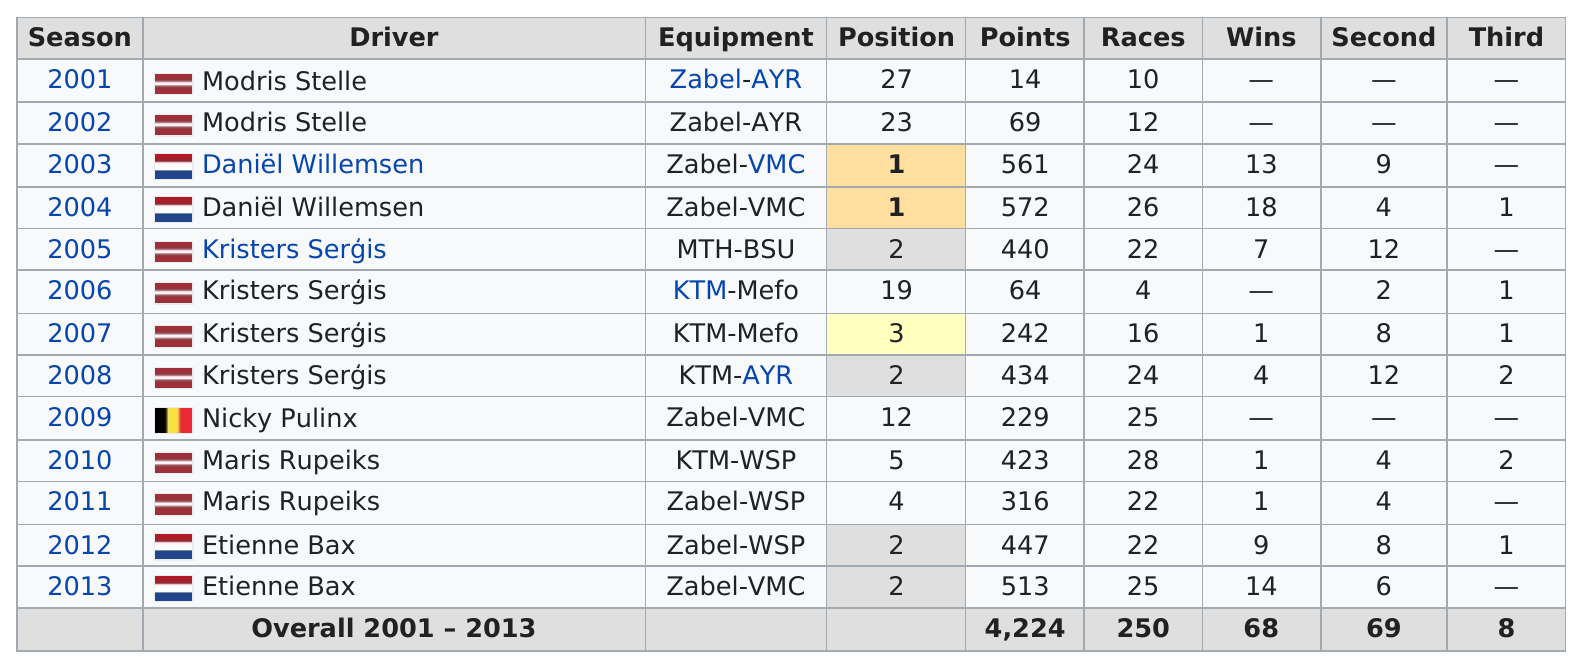Mention a couple of crucial points in this snapshot. During the 2001 season, Stelle obtained 14 points. The total number of races that took place between 2001 and 2004 is 72. Modris Stelle drove for 2 consecutive years, beginning in 2001. During the 2001-2013 season, the most commonly used equipment was Zabel-VMC. The years 2001, 2002, and 2009 had no second place drivers in the NASCAR Cup Series. 